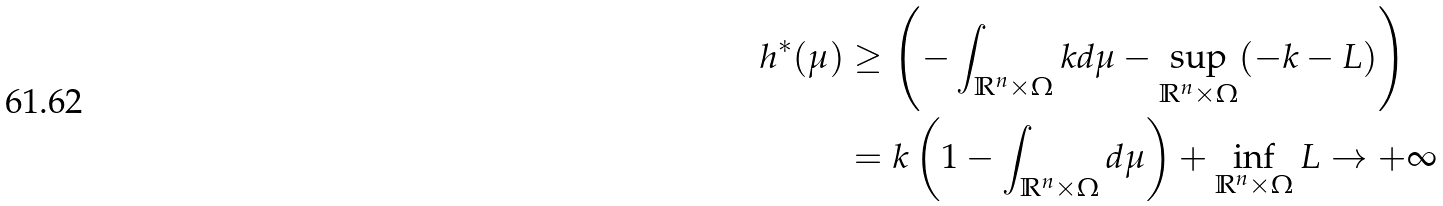<formula> <loc_0><loc_0><loc_500><loc_500>h ^ { * } ( \mu ) & \geq \left ( - \int _ { \mathbb { R } ^ { n } \times \Omega } k d \mu - \sup _ { \mathbb { R } ^ { n } \times \Omega } ( - k - L ) \right ) \\ & = k \left ( 1 - \int _ { \mathbb { R } ^ { n } \times \Omega } d \mu \right ) + \inf _ { \mathbb { R } ^ { n } \times \Omega } L \to + \infty</formula> 